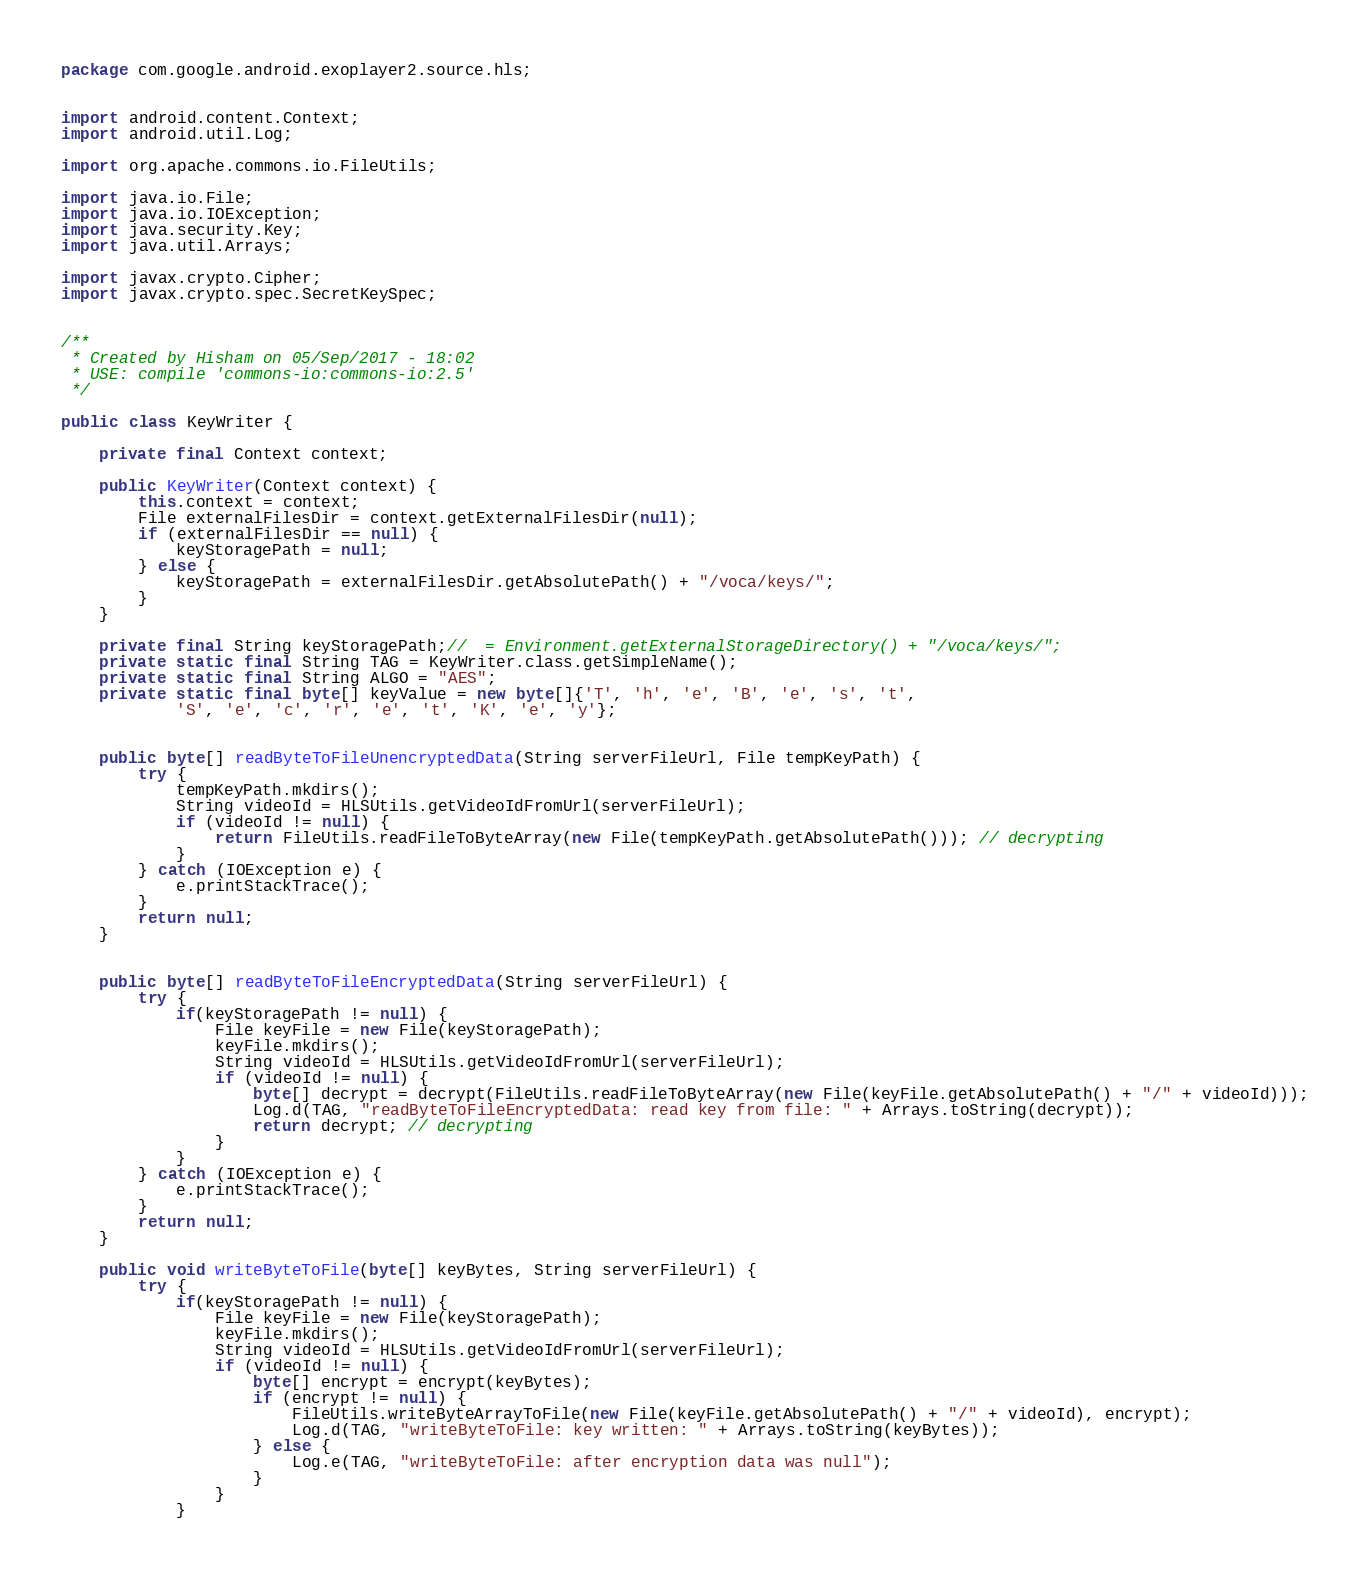Convert code to text. <code><loc_0><loc_0><loc_500><loc_500><_Java_>package com.google.android.exoplayer2.source.hls;


import android.content.Context;
import android.util.Log;

import org.apache.commons.io.FileUtils;

import java.io.File;
import java.io.IOException;
import java.security.Key;
import java.util.Arrays;

import javax.crypto.Cipher;
import javax.crypto.spec.SecretKeySpec;


/**
 * Created by Hisham on 05/Sep/2017 - 18:02
 * USE: compile 'commons-io:commons-io:2.5'
 */

public class KeyWriter {

    private final Context context;

    public KeyWriter(Context context) {
        this.context = context;
        File externalFilesDir = context.getExternalFilesDir(null);
        if (externalFilesDir == null) {
            keyStoragePath = null;
        } else {
            keyStoragePath = externalFilesDir.getAbsolutePath() + "/voca/keys/";
        }
    }

    private final String keyStoragePath;//  = Environment.getExternalStorageDirectory() + "/voca/keys/";
    private static final String TAG = KeyWriter.class.getSimpleName();
    private static final String ALGO = "AES";
    private static final byte[] keyValue = new byte[]{'T', 'h', 'e', 'B', 'e', 's', 't',
            'S', 'e', 'c', 'r', 'e', 't', 'K', 'e', 'y'};


    public byte[] readByteToFileUnencryptedData(String serverFileUrl, File tempKeyPath) {
        try {
            tempKeyPath.mkdirs();
            String videoId = HLSUtils.getVideoIdFromUrl(serverFileUrl);
            if (videoId != null) {
                return FileUtils.readFileToByteArray(new File(tempKeyPath.getAbsolutePath())); // decrypting
            }
        } catch (IOException e) {
            e.printStackTrace();
        }
        return null;
    }


    public byte[] readByteToFileEncryptedData(String serverFileUrl) {
        try {
            if(keyStoragePath != null) {
                File keyFile = new File(keyStoragePath);
                keyFile.mkdirs();
                String videoId = HLSUtils.getVideoIdFromUrl(serverFileUrl);
                if (videoId != null) {
                    byte[] decrypt = decrypt(FileUtils.readFileToByteArray(new File(keyFile.getAbsolutePath() + "/" + videoId)));
                    Log.d(TAG, "readByteToFileEncryptedData: read key from file: " + Arrays.toString(decrypt));
                    return decrypt; // decrypting
                }
            }
        } catch (IOException e) {
            e.printStackTrace();
        }
        return null;
    }

    public void writeByteToFile(byte[] keyBytes, String serverFileUrl) {
        try {
            if(keyStoragePath != null) {
                File keyFile = new File(keyStoragePath);
                keyFile.mkdirs();
                String videoId = HLSUtils.getVideoIdFromUrl(serverFileUrl);
                if (videoId != null) {
                    byte[] encrypt = encrypt(keyBytes);
                    if (encrypt != null) {
                        FileUtils.writeByteArrayToFile(new File(keyFile.getAbsolutePath() + "/" + videoId), encrypt);
                        Log.d(TAG, "writeByteToFile: key written: " + Arrays.toString(keyBytes));
                    } else {
                        Log.e(TAG, "writeByteToFile: after encryption data was null");
                    }
                }
            }</code> 